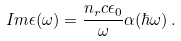<formula> <loc_0><loc_0><loc_500><loc_500>I m \/ \epsilon ( \omega ) = \frac { n _ { r } c \epsilon _ { 0 } } { \omega } \alpha ( \hbar { \omega } ) \, .</formula> 